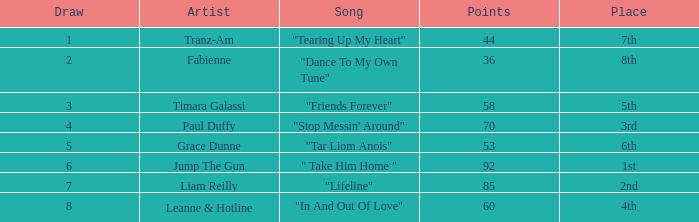What's the track by musician liam reilly? "Lifeline". 